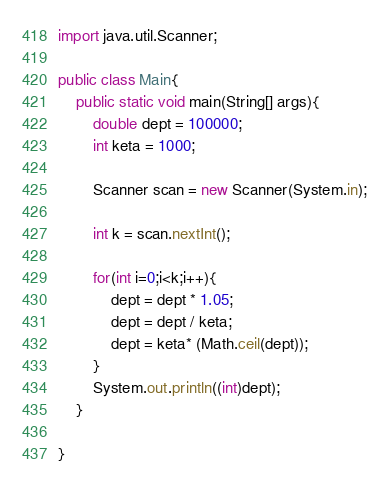<code> <loc_0><loc_0><loc_500><loc_500><_Java_>import java.util.Scanner;

public class Main{
	public static void main(String[] args){
		double dept = 100000;
		int keta = 1000;
		
		Scanner scan = new Scanner(System.in);
		
		int k = scan.nextInt();
		
		for(int i=0;i<k;i++){
			dept = dept * 1.05;
			dept = dept / keta;
			dept = keta* (Math.ceil(dept));
		}
		System.out.println((int)dept);
	}
	
}</code> 